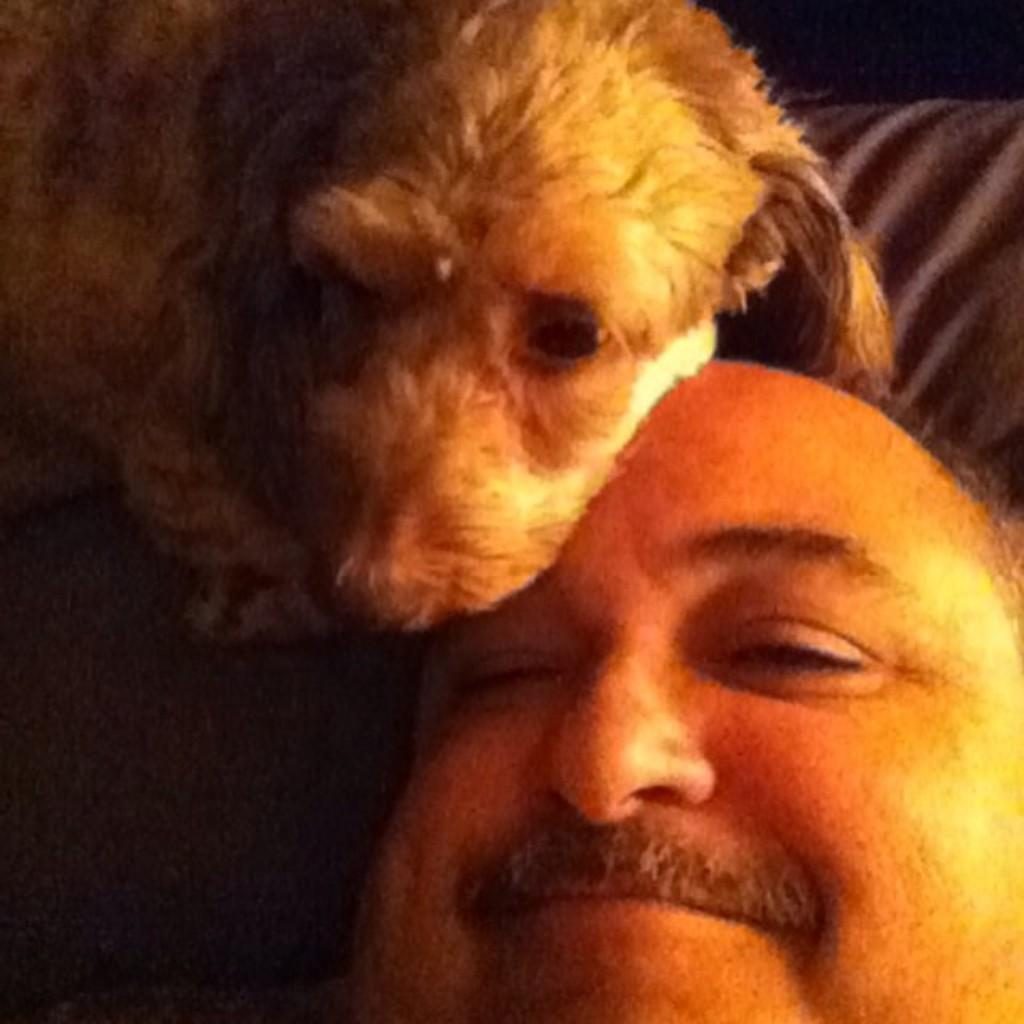What is present in the image? There is a man and a dog in the image. How is the man depicted in the image? The man is smiling in the image. Can you describe the dog in the image? The provided facts do not give any specific details about the dog, so we cannot describe it further. What type of blade is the man using to cut the potato in the image? There is no blade or potato present in the image; it only features a man and a dog. 